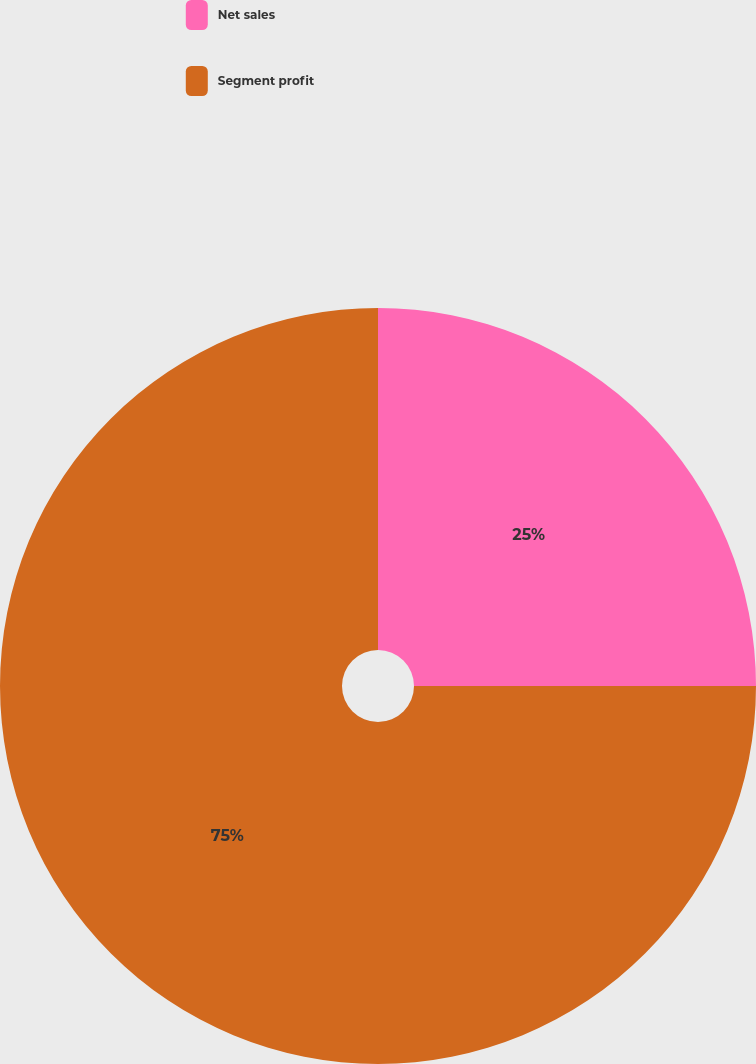<chart> <loc_0><loc_0><loc_500><loc_500><pie_chart><fcel>Net sales<fcel>Segment profit<nl><fcel>25.0%<fcel>75.0%<nl></chart> 